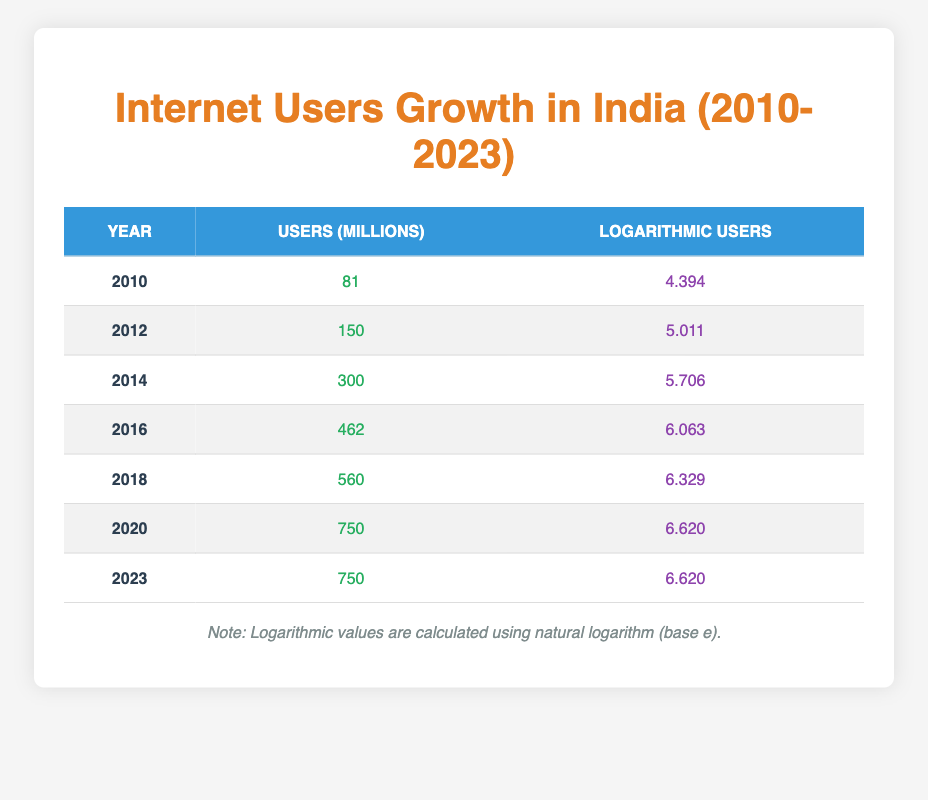What was the number of internet users in millions in 2010? The table directly shows that in the year 2010, the number of internet users was 81 million.
Answer: 81 What is the logarithmic value of internet users for the year 2018? Referring to the table, the logarithmic value of internet users in 2018 is directly given as 6.329.
Answer: 6.329 How many more internet users (in millions) were there in 2020 compared to 2012? From the table, 2020 had 750 million users and 2012 had 150 million users. The difference is 750 - 150 = 600 million users.
Answer: 600 Is it true that the number of internet users in 2014 exceeded 400 million? Checking the table, the number of internet users in 2014 is listed as 300 million, which is less than 400 million. Therefore, this statement is false.
Answer: False What was the average number of users (in millions) from 2010 to 2023? To find the average, sum the values: 81 + 150 + 300 + 462 + 560 + 750 + 750 = 3053. There are 7 years, so the average is 3053 / 7 ≈ 436.14 million.
Answer: Approximately 436.14 How much did the logarithmic value increase from 2010 to 2016? The logarithmic value in 2010 is 4.394 and in 2016 it is 6.063. The increase is calculated as 6.063 - 4.394 = 1.669.
Answer: 1.669 Was there any year between 2010 and 2023 when the internet users decreased? Looking at the table, there is no year listed where the number of internet users decreased; the figures only show growth or stability.
Answer: No What was the difference in the number of users between 2018 and 2016? From the table, 2018 had 560 million users and 2016 had 462 million users. The difference is 560 - 462 = 98 million users.
Answer: 98 How many years had internet users over 600 million from 2010 to 2023? Referring to the table, the years 2016, 2018, 2020, and 2023 had more than 600 million users, making a total of 4 years.
Answer: 4 